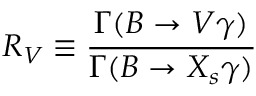Convert formula to latex. <formula><loc_0><loc_0><loc_500><loc_500>R _ { V } \equiv \frac { \Gamma ( B \to V \gamma ) } { \Gamma ( B \to X _ { s } \gamma ) }</formula> 